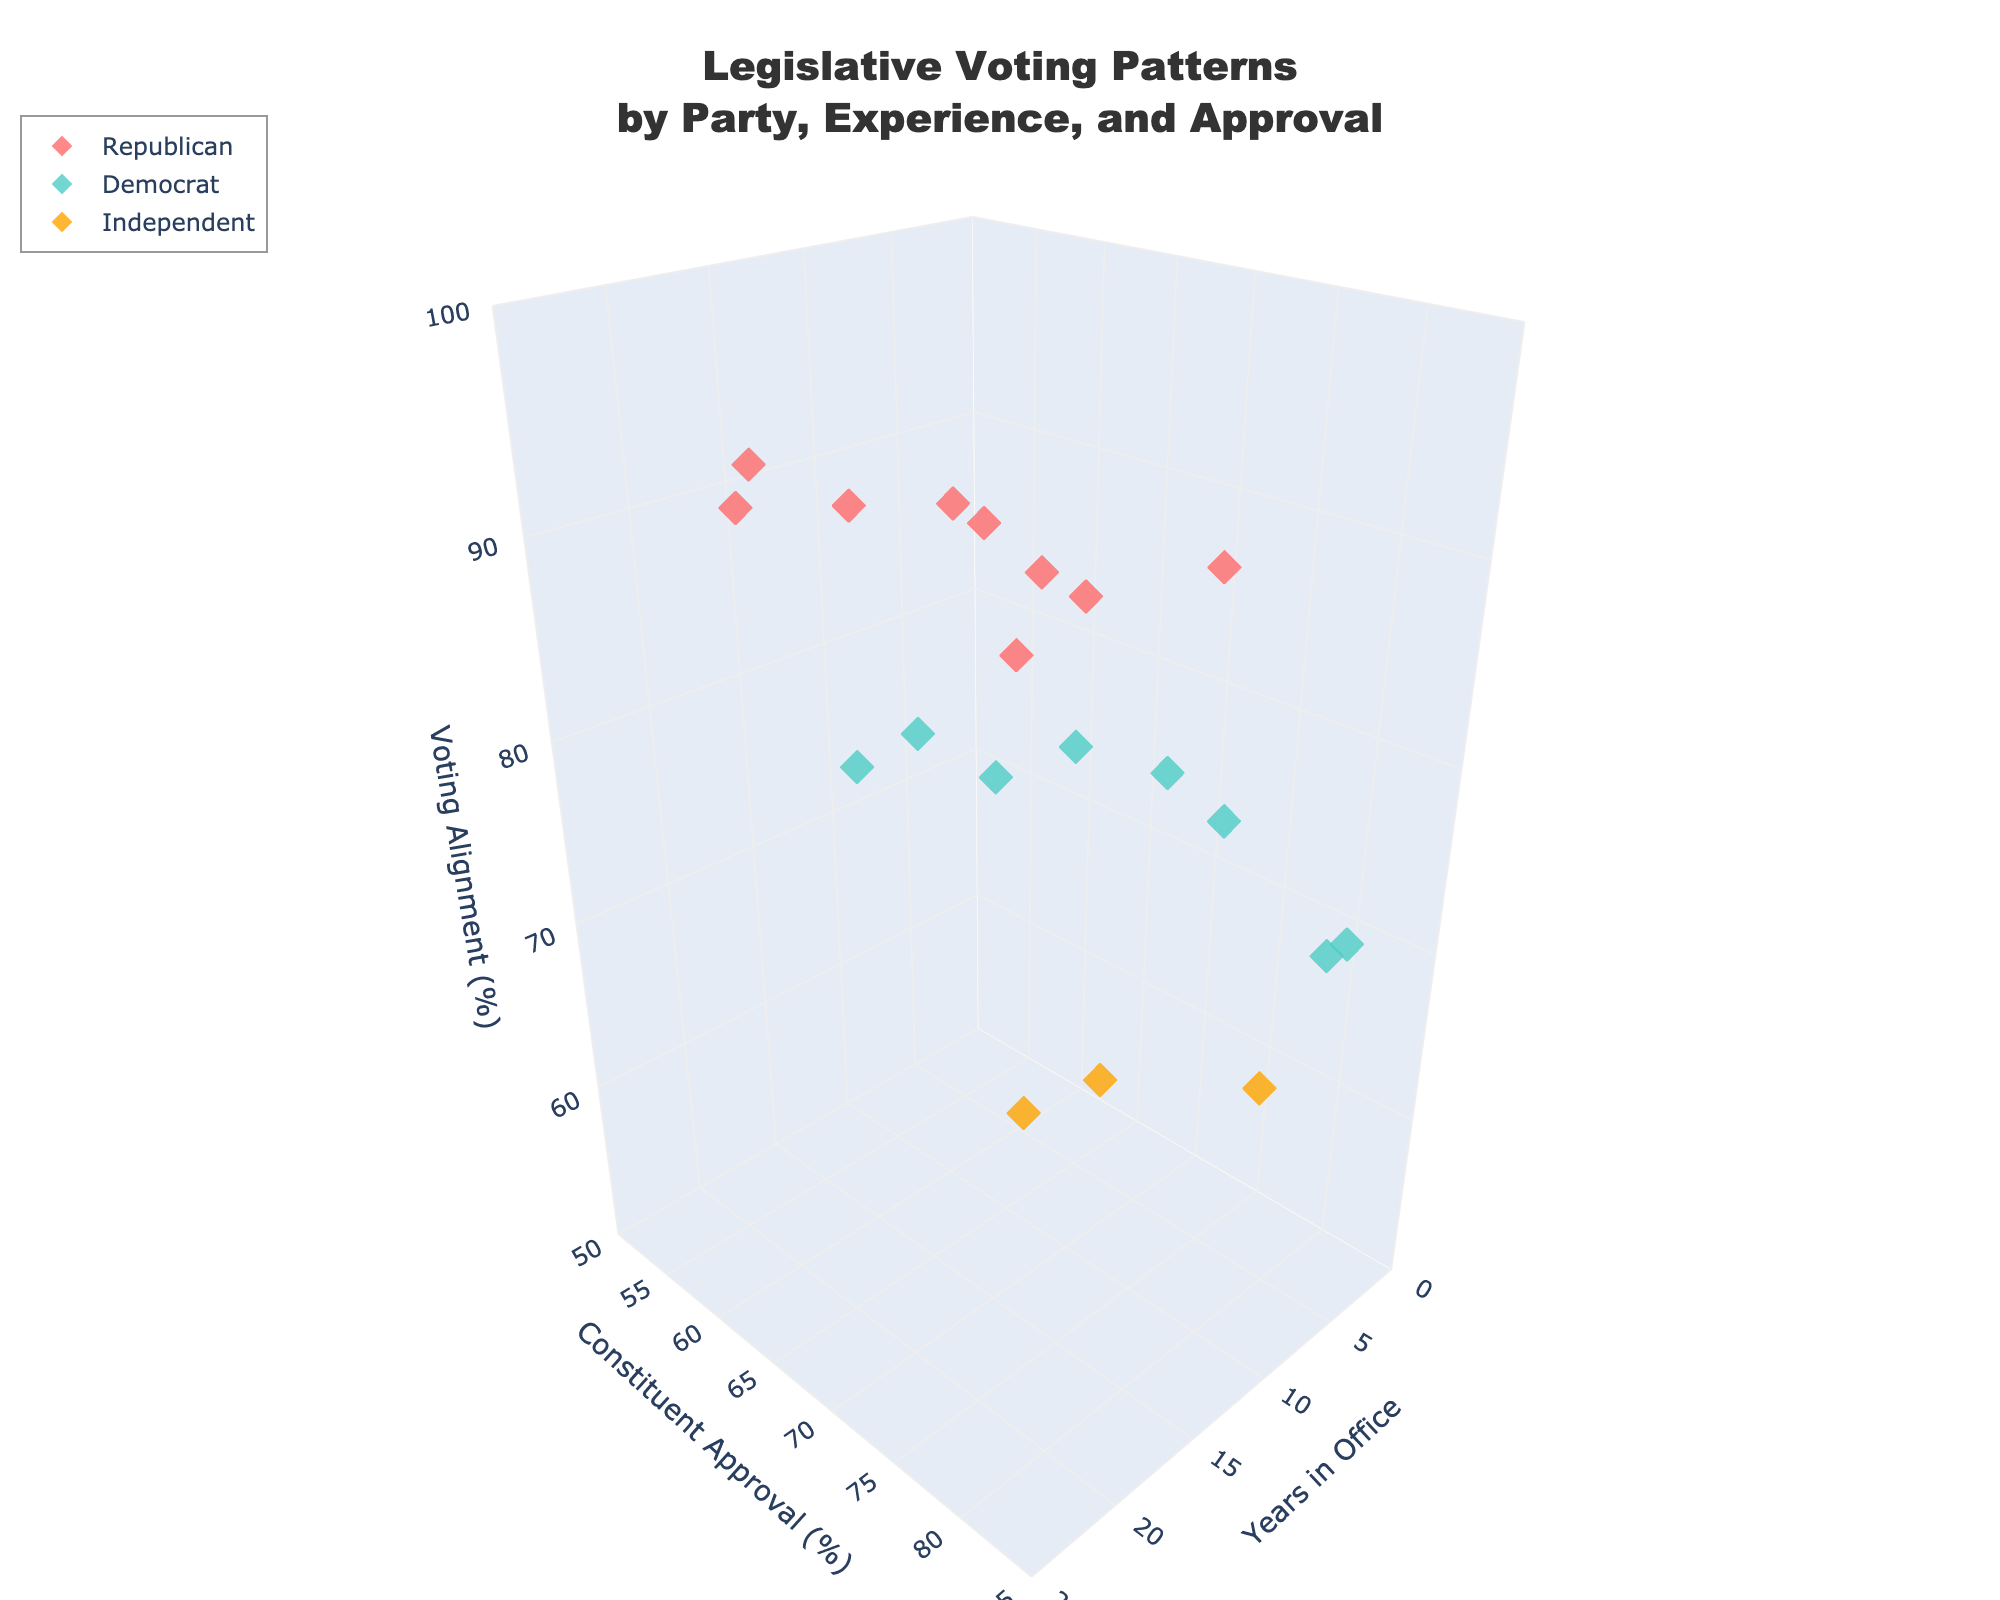How many data points are there for Republicans? Visual inspection shows 8 data points colored uniquely for Republicans.
Answer: 8 What is the title of the figure? The title is located at the top of the plot and reads: "Legislative Voting Patterns by Party, Experience, and Approval".
Answer: Legislative Voting Patterns by Party, Experience, and Approval Which party has the data point with the lowest years in office? By looking at the x-axis which represents Years in Office and identifying the lowest value, the Democrat party has a data point with only 1 year in office.
Answer: Democrat What is the range of the y-axis representing Constituent Approval? The y-axis range extends from 50% to 85%, as indicated on the axis.
Answer: 50 to 85 Which party has the data point with the highest Voting Alignment? The data point highest on the z-axis (Voting Alignment) represents the Republican party with a value of 93%.
Answer: Republican Calculate the average years in office for Democratic legislators. The years for Democrat legislators are 6, 2, 16, 22, 14, 5, 11, 1. Sum them up to get 77, and the average is 77/8 = 9.625.
Answer: 9.625 Compare the Constituent Approval of the longest-serving Independent legislator with the shortest-serving Democrat legislator. The longest-serving Independent legislator has 8 years and an Approval of 64%. The shortest-serving Democrat legislator has 1 year and an Approval of 79%. 79% is greater than 64%.
Answer: Democrat Which party shows the largest spread in Voting Alignment? By examining the highest and lowest points on the z-axis for each party: Republicans range from 85 to 93 (spread of 8), Democrats range from 68 to 84 (spread of 16), Independents range from 55 to 60 (spread of 5). Democrats show the largest spread.
Answer: Democrat What is the average Constituent Approval for legislators in office for more than 10 years? Identify data points with more than 10 years: Republican(20, 18, 12), Democrat(22, 16, 14, 11). The respective approvals are 59, 57, 68, 70, 66, 69, 71. Average is (59+57+68+70+66+69+71)/7 = 65.714.
Answer: 65.714 